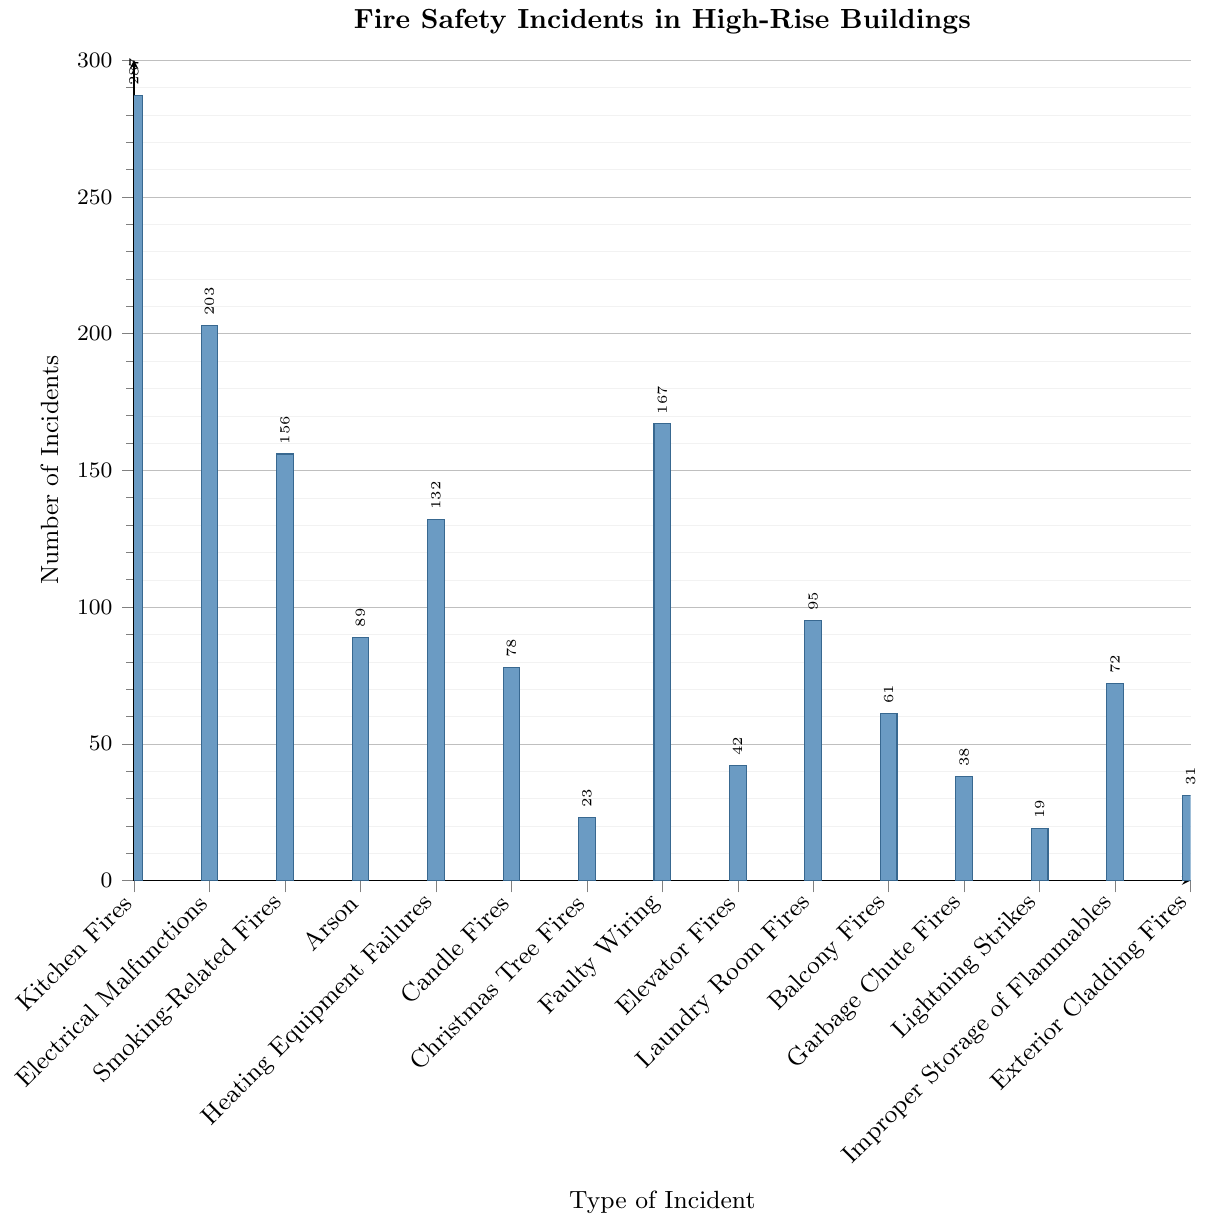What type of incident has the highest number of fire safety incidents in high-rise buildings? Look at the height of the bars. The tallest bar corresponds to 'Kitchen Fires'.
Answer: Kitchen Fires Which type of incident occurs more frequently: Arson or Balcony Fires? Compare the heights of the bars for Arson and Balcony Fires. The bar for Arson is taller.
Answer: Arson How many more incidents were caused by Electrical Malfunctions than by Candle Fires? Subtract the number of Candle Fires (78) from the number of Electrical Malfunctions (203). 203 - 78 = 125
Answer: 125 Which incident type has the fewest number of incidents? The shortest bar corresponds to 'Lightning Strikes'.
Answer: Lightning Strikes What is the average number of incidents for Elevator Fires, Laundry Room Fires, and Garbage Chute Fires? Add the incidents for Elevator Fires (42), Laundry Room Fires (95), and Garbage Chute Fires (38), then divide by 3. (42 + 95 + 38) / 3 = 175 / 3 ≈ 58.33
Answer: 58.33 Are there more Heating Equipment Failures or Faulty Wiring incidents? Compare the heights of the bars for Heating Equipment Failures and Faulty Wiring. The bar for Faulty Wiring is taller.
Answer: Faulty Wiring How many total incidents are caused by Smoke-Related Fires, Christmas Tree Fires, and Improper Storage of Flammables combined? Add the number of incidents for each category: Smoking-Related Fires (156) + Christmas Tree Fires (23) + Improper Storage of Flammables (72). 156 + 23 + 72 = 251
Answer: 251 Which category has more incidents, Balcony Fires or Exterior Cladding Fires? Compare the heights of the bars for Balcony Fires and Exterior Cladding Fires. The bar for Balcony Fires is taller.
Answer: Balcony Fires Which incidents have a higher count, Lighting Strikes or Christmas Tree Fires? Compare the heights of the bars for Lightning Strikes and Christmas Tree Fires. The bar for Christmas Tree Fires is taller.
Answer: Christmas Tree Fires 